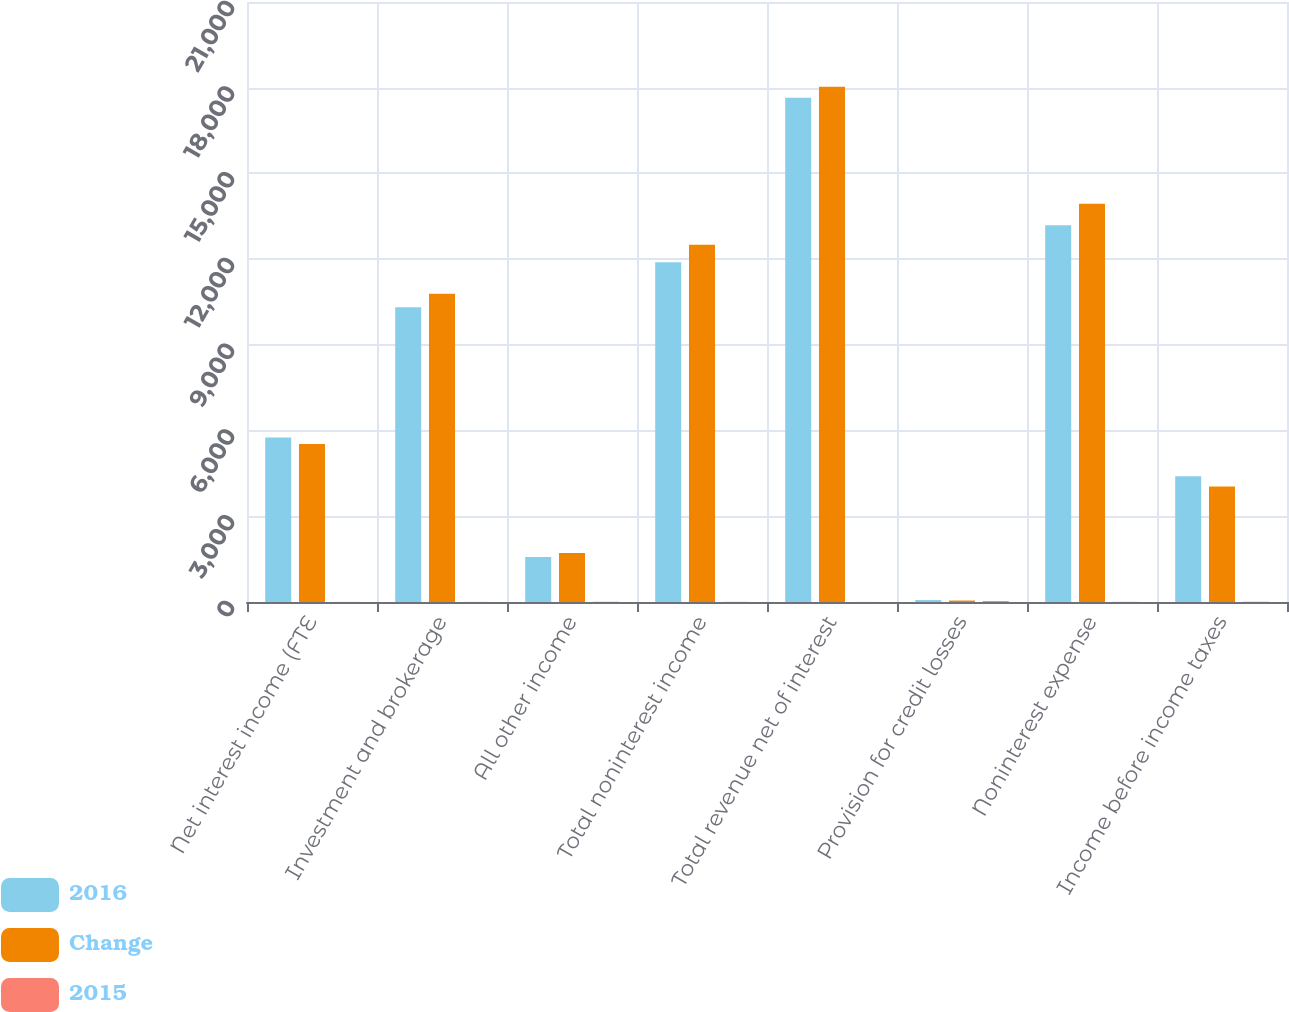Convert chart to OTSL. <chart><loc_0><loc_0><loc_500><loc_500><stacked_bar_chart><ecel><fcel>Net interest income (FTE<fcel>Investment and brokerage<fcel>All other income<fcel>Total noninterest income<fcel>Total revenue net of interest<fcel>Provision for credit losses<fcel>Noninterest expense<fcel>Income before income taxes<nl><fcel>2016<fcel>5759<fcel>10316<fcel>1575<fcel>11891<fcel>17650<fcel>68<fcel>13182<fcel>4400<nl><fcel>Change<fcel>5527<fcel>10792<fcel>1715<fcel>12507<fcel>18034<fcel>51<fcel>13943<fcel>4040<nl><fcel>2015<fcel>4<fcel>4<fcel>8<fcel>5<fcel>2<fcel>33<fcel>5<fcel>9<nl></chart> 